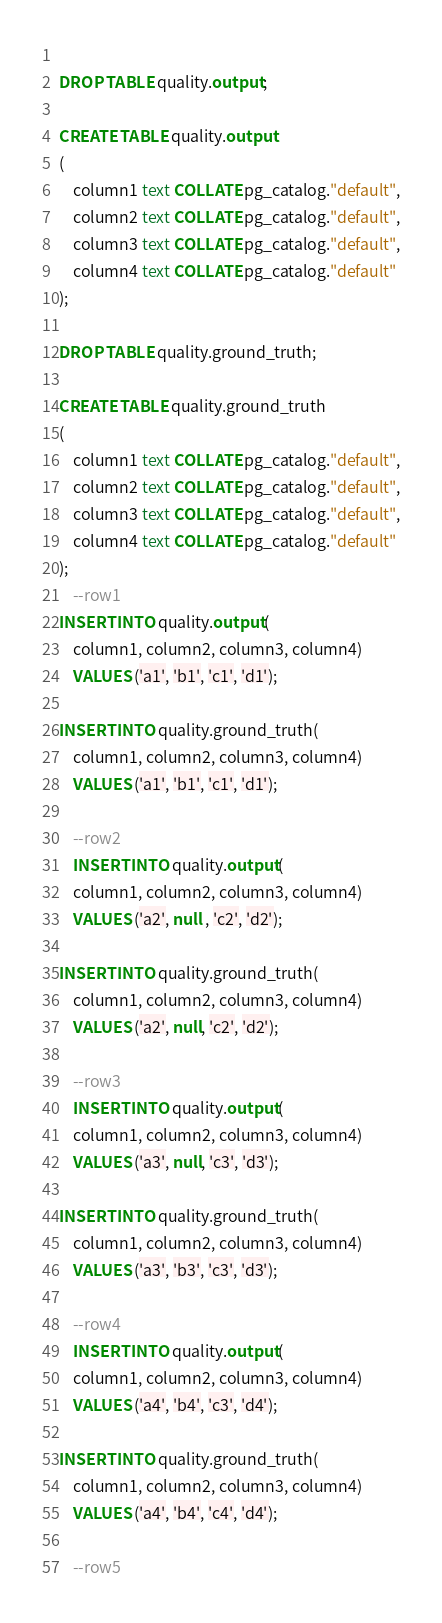Convert code to text. <code><loc_0><loc_0><loc_500><loc_500><_SQL_>	
DROP TABLE quality.output;

CREATE TABLE quality.output
(
    column1 text COLLATE pg_catalog."default",
    column2 text COLLATE pg_catalog."default",
    column3 text COLLATE pg_catalog."default",
    column4 text COLLATE pg_catalog."default"
);   

DROP TABLE quality.ground_truth;

CREATE TABLE quality.ground_truth
(
    column1 text COLLATE pg_catalog."default",
    column2 text COLLATE pg_catalog."default",
    column3 text COLLATE pg_catalog."default",
    column4 text COLLATE pg_catalog."default"
);
    --row1
INSERT INTO quality.output(
	column1, column2, column3, column4)
	VALUES ('a1', 'b1', 'c1', 'd1');

INSERT INTO quality.ground_truth(
	column1, column2, column3, column4)
	VALUES ('a1', 'b1', 'c1', 'd1');
	
	--row2
	INSERT INTO quality.output(
	column1, column2, column3, column4)
	VALUES ('a2', null , 'c2', 'd2');

INSERT INTO quality.ground_truth(
	column1, column2, column3, column4)
	VALUES ('a2', null, 'c2', 'd2');
	
	--row3
	INSERT INTO quality.output(
	column1, column2, column3, column4)
	VALUES ('a3', null, 'c3', 'd3');

INSERT INTO quality.ground_truth(
	column1, column2, column3, column4)
	VALUES ('a3', 'b3', 'c3', 'd3');
	
	--row4
	INSERT INTO quality.output(
	column1, column2, column3, column4)
	VALUES ('a4', 'b4', 'c3', 'd4');

INSERT INTO quality.ground_truth(
	column1, column2, column3, column4)
	VALUES ('a4', 'b4', 'c4', 'd4');
	
	--row5</code> 